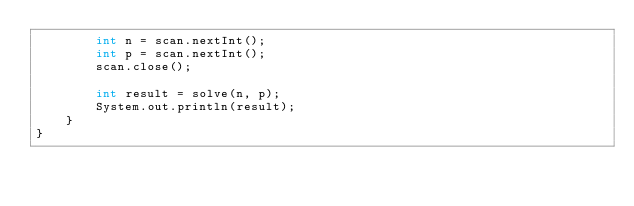Convert code to text. <code><loc_0><loc_0><loc_500><loc_500><_Java_>        int n = scan.nextInt();
        int p = scan.nextInt();
        scan.close();
        
        int result = solve(n, p);
        System.out.println(result);
    }
}
</code> 